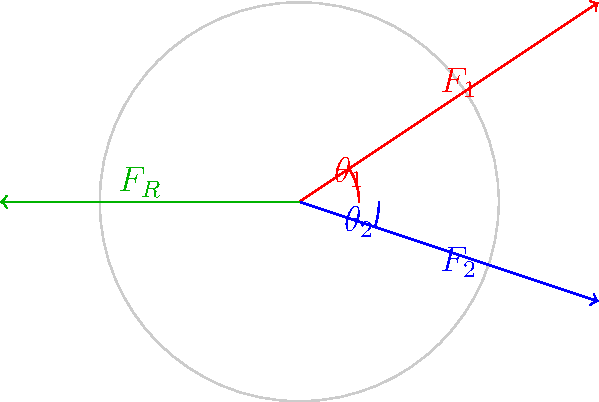During a tackle, John Geraghty's shoulder experiences two forces: $F_1 = 800$ N at an angle of $33.69°$ above the horizontal, and $F_2 = 600$ N at an angle of $18.43°$ below the horizontal. What is the magnitude of the resultant force $F_R$ on his shoulder? To find the resultant force, we need to follow these steps:

1) Decompose each force into its x and y components:

   $F_{1x} = F_1 \cos(\theta_1) = 800 \cos(33.69°) = 665.3$ N
   $F_{1y} = F_1 \sin(\theta_1) = 800 \sin(33.69°) = 444.4$ N
   
   $F_{2x} = F_2 \cos(\theta_2) = 600 \cos(18.43°) = 569.0$ N
   $F_{2y} = -F_2 \sin(\theta_2) = -600 \sin(18.43°) = -189.5$ N

2) Sum the x and y components:

   $F_x = F_{1x} + F_{2x} = 665.3 + 569.0 = 1234.3$ N
   $F_y = F_{1y} + F_{2y} = 444.4 + (-189.5) = 254.9$ N

3) Calculate the magnitude of the resultant force using the Pythagorean theorem:

   $F_R = \sqrt{F_x^2 + F_y^2} = \sqrt{1234.3^2 + 254.9^2} = 1261.5$ N

Therefore, the magnitude of the resultant force on John's shoulder is approximately 1261.5 N.
Answer: 1261.5 N 